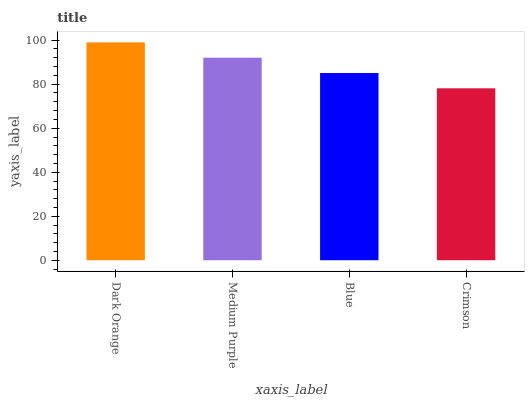Is Crimson the minimum?
Answer yes or no. Yes. Is Dark Orange the maximum?
Answer yes or no. Yes. Is Medium Purple the minimum?
Answer yes or no. No. Is Medium Purple the maximum?
Answer yes or no. No. Is Dark Orange greater than Medium Purple?
Answer yes or no. Yes. Is Medium Purple less than Dark Orange?
Answer yes or no. Yes. Is Medium Purple greater than Dark Orange?
Answer yes or no. No. Is Dark Orange less than Medium Purple?
Answer yes or no. No. Is Medium Purple the high median?
Answer yes or no. Yes. Is Blue the low median?
Answer yes or no. Yes. Is Dark Orange the high median?
Answer yes or no. No. Is Crimson the low median?
Answer yes or no. No. 